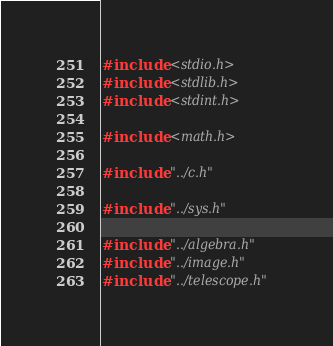<code> <loc_0><loc_0><loc_500><loc_500><_C_>#include <stdio.h>
#include <stdlib.h>
#include <stdint.h>

#include <math.h>

#include "../c.h"

#include "../sys.h"

#include "../algebra.h"
#include "../image.h"
#include "../telescope.h"
</code> 